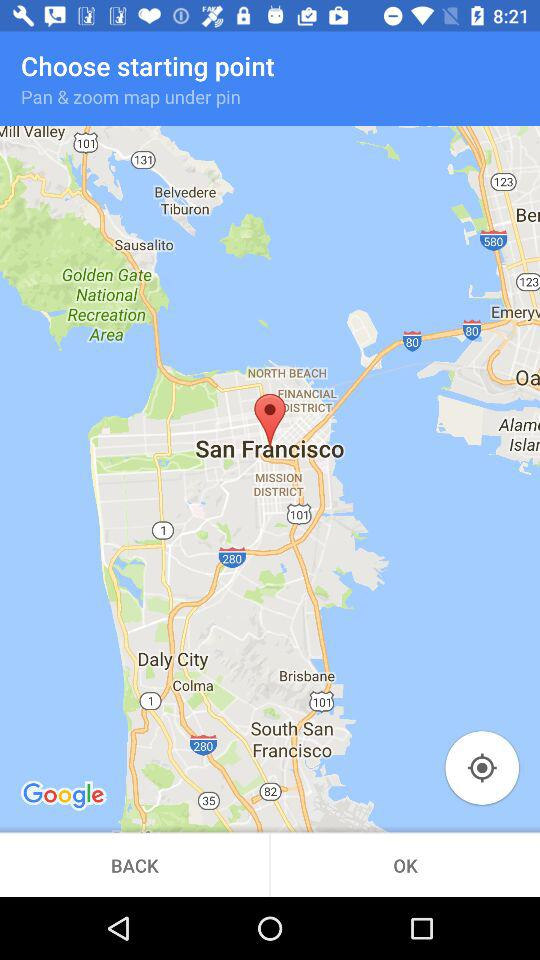Which is the pinpoint city? The pinpoint city is San Francisco. 